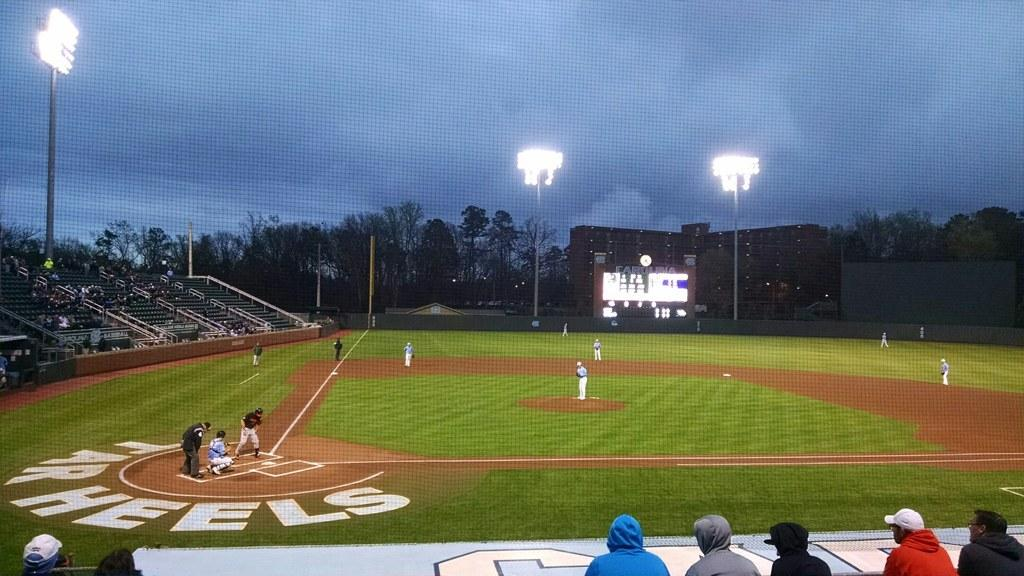<image>
Summarize the visual content of the image. A baseball field with the words Tar Heels behind the home plate ready for play 